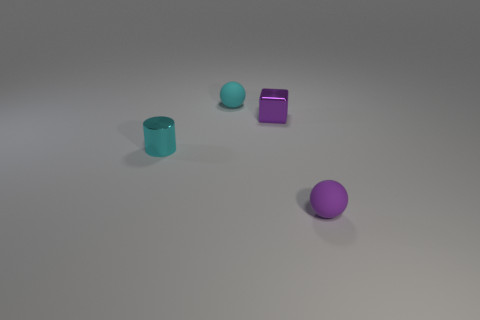What number of cubes are small purple things or tiny cyan shiny things?
Offer a very short reply. 1. Are there any tiny red rubber things?
Offer a terse response. No. Is there anything else that is the same shape as the tiny cyan shiny thing?
Your response must be concise. No. How many objects are small cyan things that are in front of the metal block or green shiny cubes?
Your answer should be compact. 1. There is a matte ball that is to the left of the small matte object that is in front of the cyan metal thing; what number of cyan matte balls are behind it?
Give a very brief answer. 0. What is the shape of the purple object that is to the left of the tiny purple object in front of the cyan cylinder that is left of the small purple block?
Keep it short and to the point. Cube. What number of other things are there of the same color as the small cube?
Your answer should be compact. 1. What shape is the tiny purple thing that is in front of the tiny cyan cylinder to the left of the purple ball?
Your response must be concise. Sphere. How many small metal things are right of the cyan metallic cylinder?
Ensure brevity in your answer.  1. Are there any small purple cylinders made of the same material as the purple sphere?
Give a very brief answer. No. 